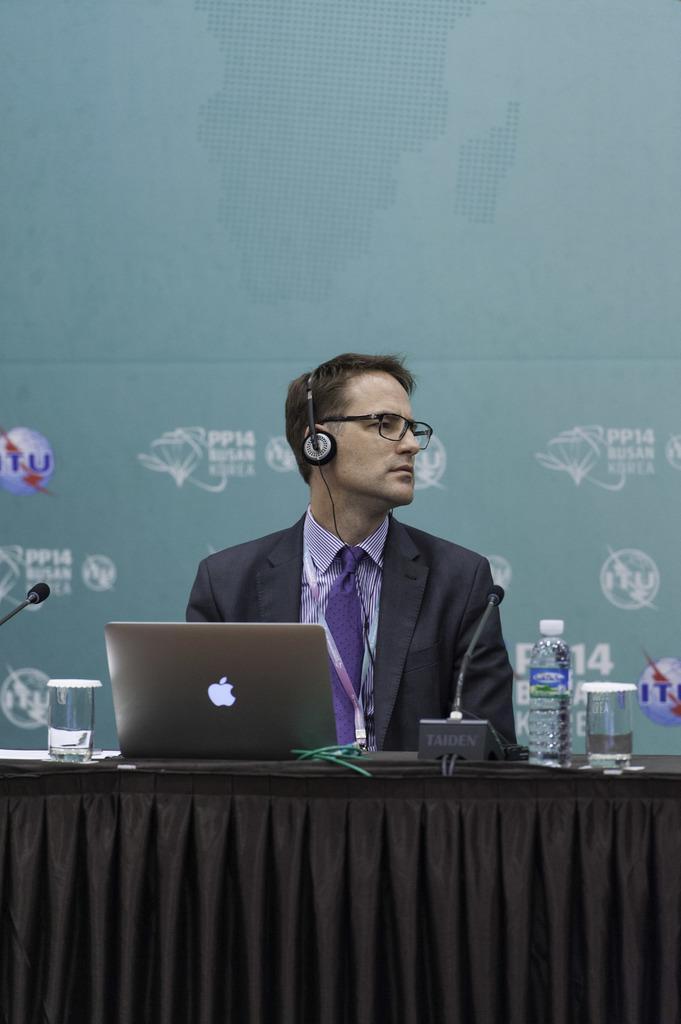In one or two sentences, can you explain what this image depicts? In this image, we can see a person sitting and wearing headset and we can see a laptop, bottle, glasses, a mic and some other objects on the stand. In the background, there is some text and logos on the board. 